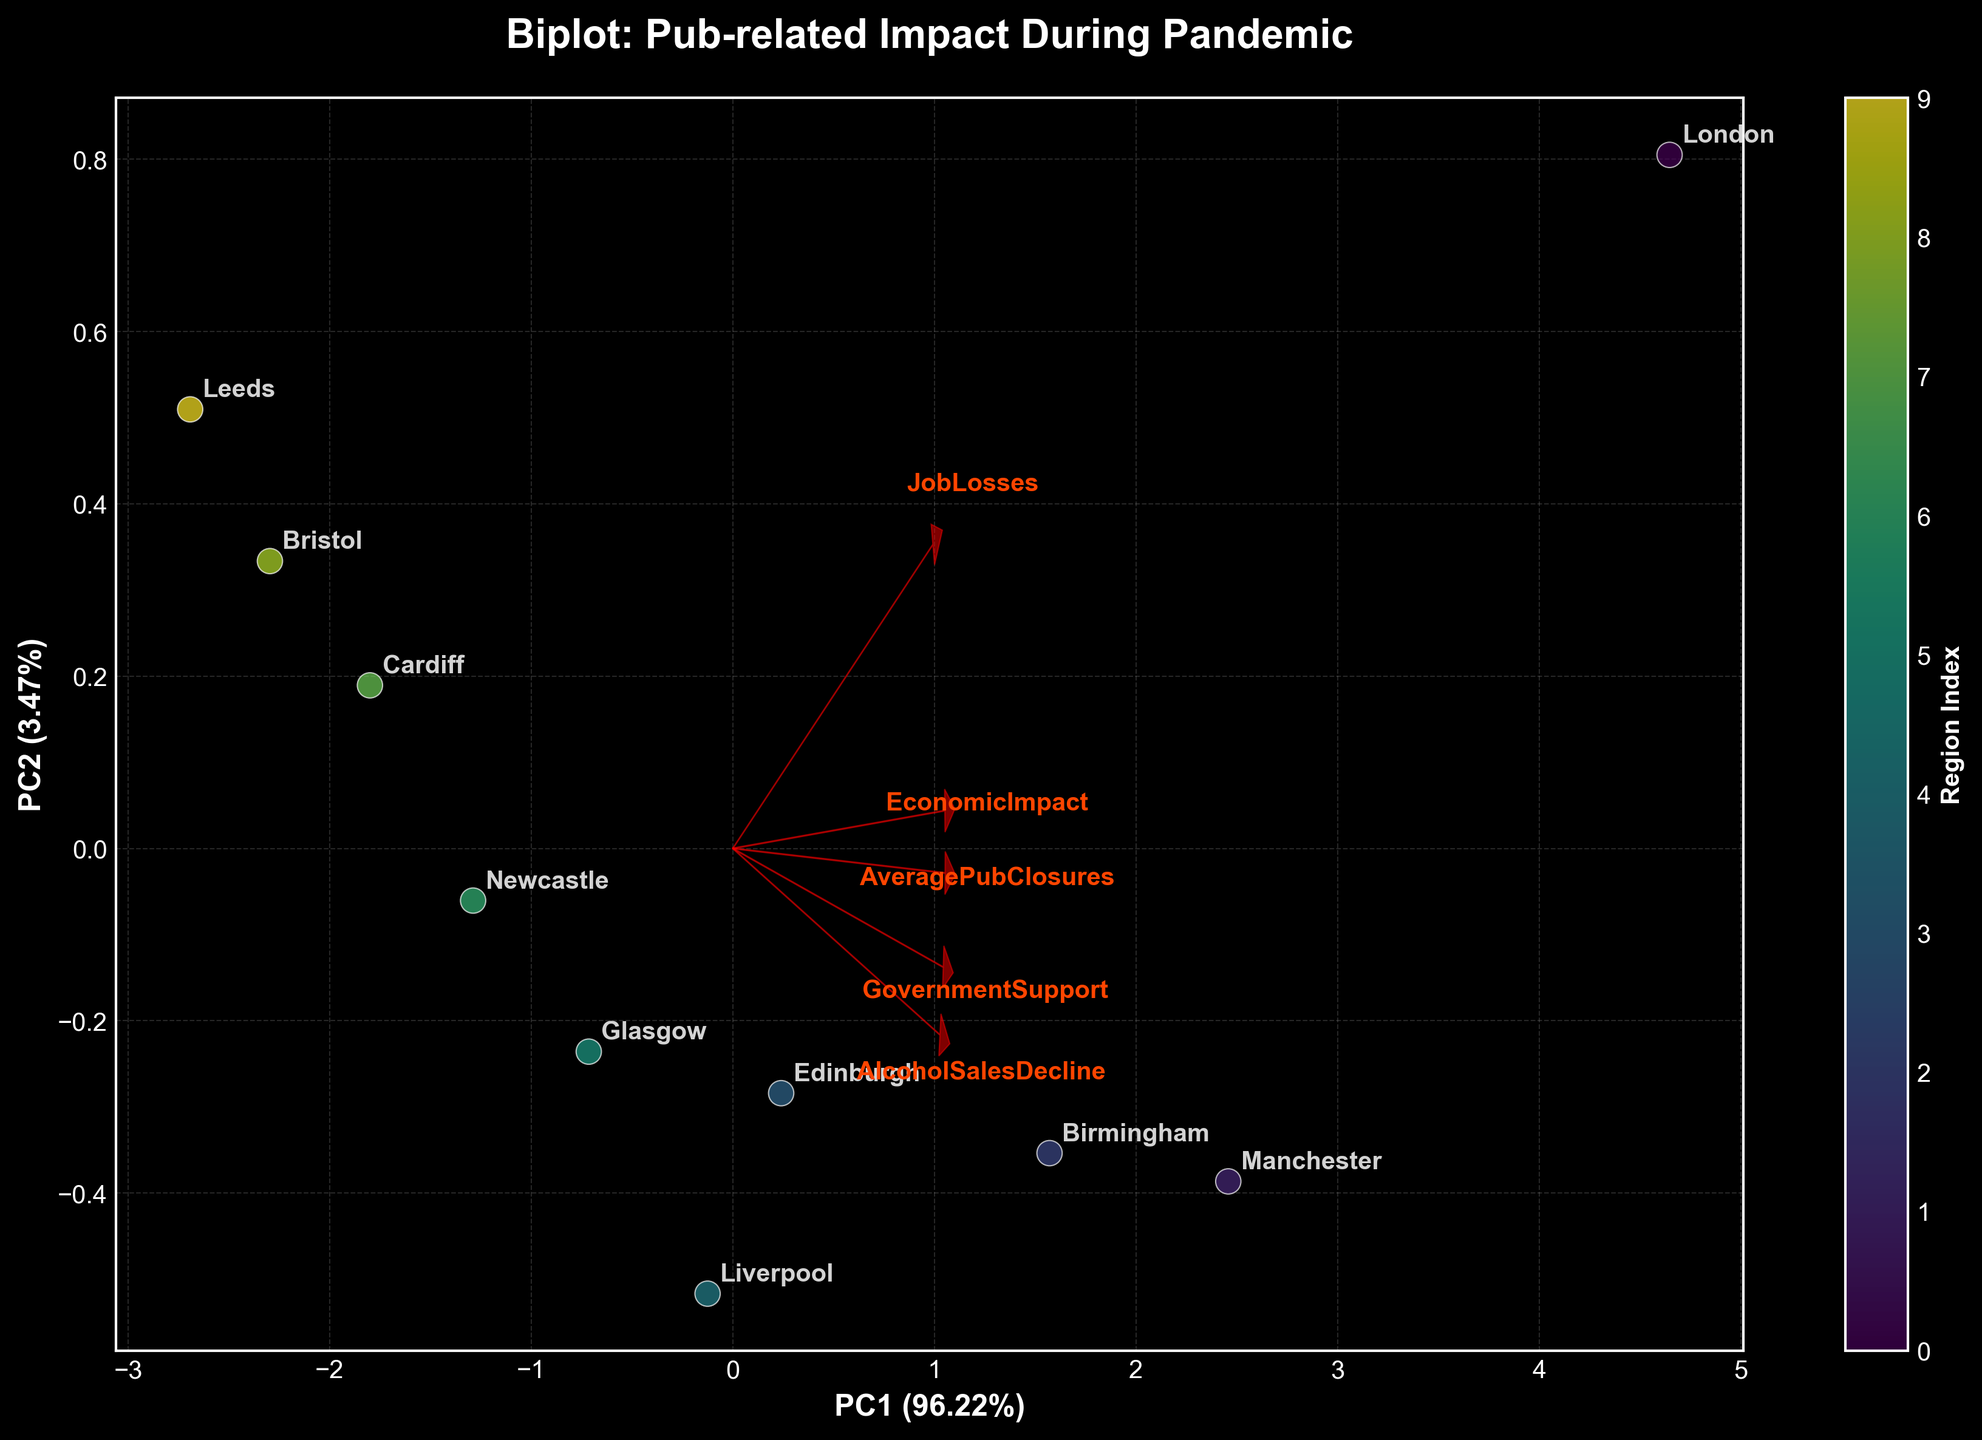What is the title of the plot? The plot title is positioned at the top-center of the figure. It is displayed in bold with clear wording.
Answer: Biplot: Pub-related Impact During Pandemic How many regions are visualized in the biplot? The biplot uses color-coded scatter points, each representing a different region. By counting these points, you can determine the number of regions shown.
Answer: 10 Which axis represents PC1 and what percentage of the variance does it explain? The PC1 axis is labeled along the x-axis. The label includes a percentage value indicating the variance explained.
Answer: PC1 (explains ~55%) Which region corresponds to the highest job losses according to the plot? Look for the data point that aligns closely with the "JobLosses" feature direction arrow. The corresponding region annotation nearby will indicate the answer.
Answer: London Which feature explains the most variance in the data along PC2? Identify the feature arrow that extends furthest along the y-axis (PC2). The length of the arrow indicates its contribution to the variance.
Answer: AveragePubClosures How are the regions Manchester and Birmingham positioned relative to each other on the plot? Locate the scatter points and labels for Manchester and Birmingham. Compare their positions on both PC1 and PC2 axes.
Answer: Close, with slight separation along PC2 Which two features are most closely related according to the feature vectors? Examine the direction of the red arrows representing feature vectors. Arrows pointing in similar directions indicate strong correlations.
Answer: AlcoholSalesDecline and AveragePubClosures By what feature are Newcastle and Cardiff most similar, and how can you tell? Look for the alignment of Newcastle and Cardiff points relative to the arrows. They align closely with a specific feature's arrow.
Answer: GovernmentSupport How does the economic impact differ between London and Bristol based on the plot? Compare the positions of London and Bristol along the axis related to EconomicImpact (PC1 or PC2). Determine the relative difference in distance from the center.
Answer: London has a higher economic impact than Bristol Which feature contributes least to the variance explained by PC1 and PC2? The feature with the shortest arrow relative to the plot origin has the least contribution. This indicates its limited influence on the explained variance.
Answer: GovernmentSupport 